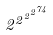Convert formula to latex. <formula><loc_0><loc_0><loc_500><loc_500>2 ^ { 2 ^ { 2 ^ { 2 ^ { 7 4 } } } }</formula> 